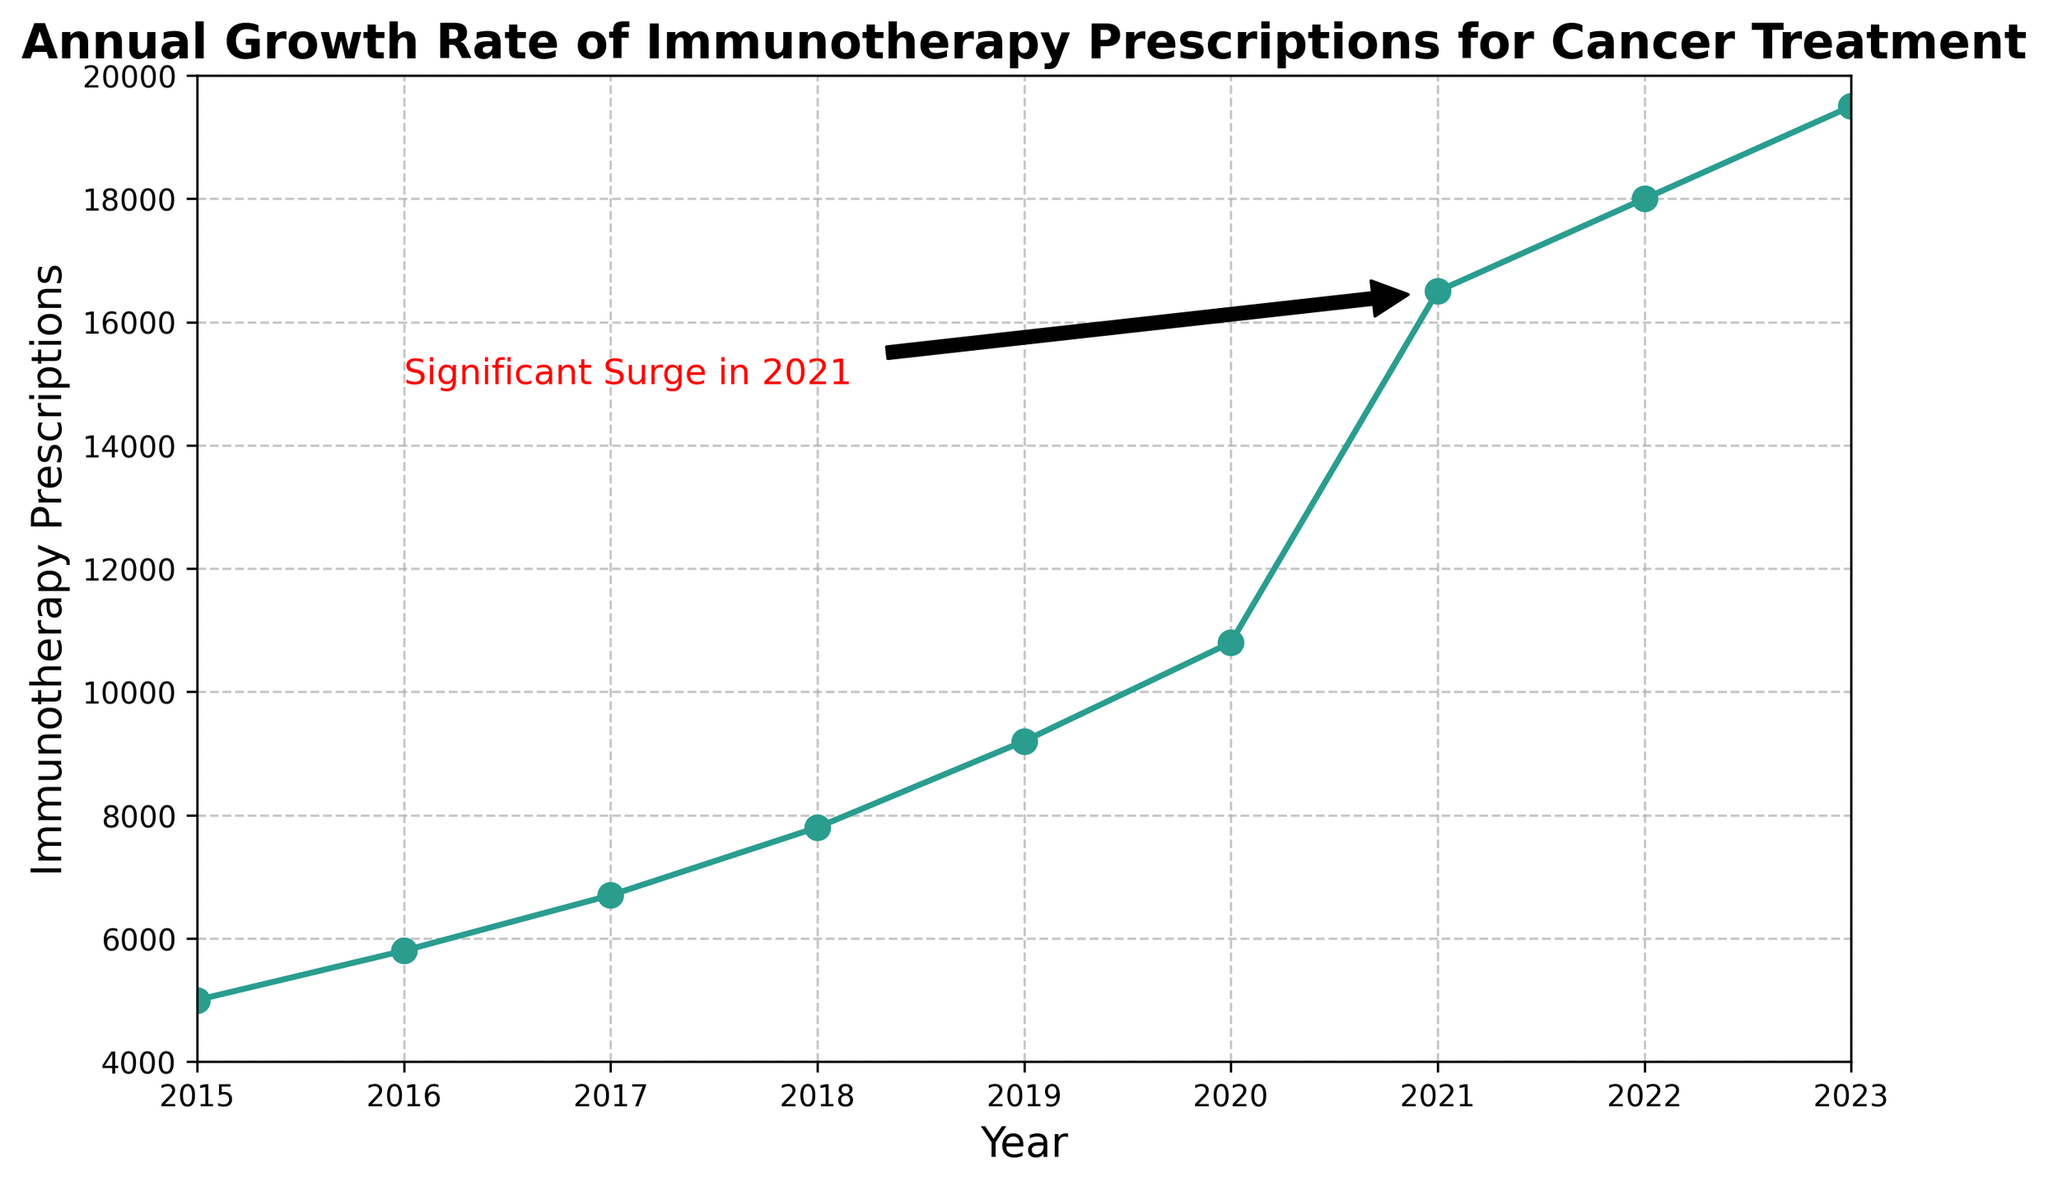What's the approximate percentage increase in the number of immunotherapy prescriptions from 2020 to 2021? The number of prescriptions in 2020 is 10,800 and in 2021 is 16,500. To find the percentage increase, use the formula: [(16,500 - 10,800) / 10,800] * 100. This calculation results in approximately 52.78%.
Answer: 52.78% In which year did the number of immunotherapy prescriptions first exceed 10,000? By looking at the chart, the number first exceeds 10,000 in the year 2020. This is where the upward trend crosses the 10,000 mark.
Answer: 2020 What is the difference in the number of prescriptions between the year with the highest and the year with the lowest prescriptions? The year with the highest prescriptions is 2023 (19,500), and the year with the lowest is 2015 (5,000). The difference is 19,500 - 5,000 = 14,500.
Answer: 14,500 How many years are there between the significant surge in 2021 and the point where the number of prescriptions started increasing? According to the chart, the initial data point is in 2015, and the significant surge is in 2021. The number of years between them is 2021 - 2015 = 6 years.
Answer: 6 years What is the average number of immunotherapy prescriptions from 2015 to 2023? Adding all the prescription values: 5,000 + 5,800 + 6,700 + 7,800 + 9,200 + 10,800 + 16,500 + 18,000 + 19,500 = 99,300. Dividing by the number of years (9) gives an average of 99,300 / 9 ≈ 11,033.33.
Answer: 11,033.33 How many times higher is the prescription count in 2021 compared to 2015? The prescription count in 2021 is 16,500 while in 2015 it is 5,000. The ratio is 16,500 / 5,000 = 3.3.
Answer: 3.3 times Which year saw the smallest increase in prescriptions compared to the previous year? By comparing year-to-year increases: 2015 to 2016 (800), 2016 to 2017 (900), 2017 to 2018 (1,100), 2018 to 2019 (1,400), 2019 to 2020 (1,600), 2020 to 2021 (5,700), 2021 to 2022 (1,500), and 2022 to 2023 (1,500). The smallest increase is from 2015 to 2016 with an increase of only 800.
Answer: 2015 to 2016 What is the trend in the number of prescriptions from 2015 to 2023? The line chart shows a steadily increasing trend in the number of immunotherapy prescriptions, with a significant surge in 2021.
Answer: Increasing trend Describe the annotation on the chart. The annotation marks the significant surge in 2021, pointing to a sharp increase in the number of prescriptions for that year. It includes an arrow pointing to the data point corresponding to 2021, with the text "Significant Surge in 2021" written in red.
Answer: Significant surge in 2021 